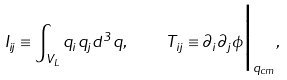<formula> <loc_0><loc_0><loc_500><loc_500>I _ { i j } \equiv \int _ { V _ { L } } q _ { i } q _ { j } d ^ { 3 } q , \quad T _ { i j } \equiv \partial _ { i } \partial _ { j } \phi \Big { | } _ { { q } _ { c m } } ,</formula> 